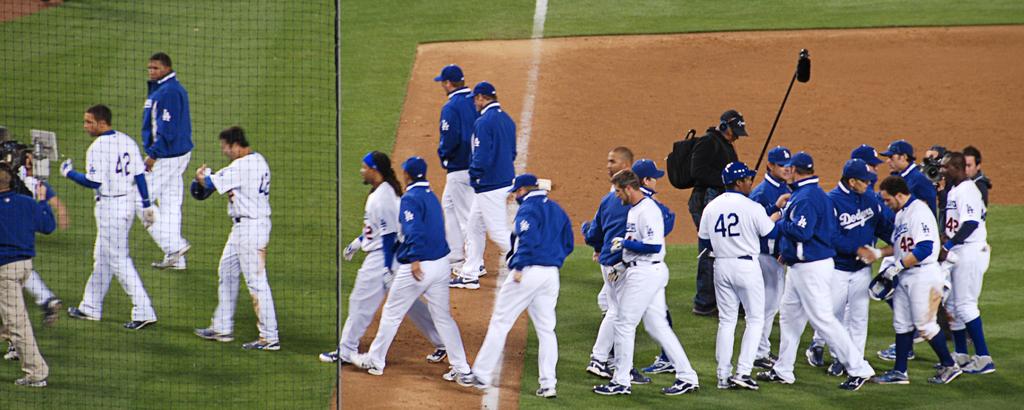What number can be seen on one of the jerseys in white?
Offer a very short reply. 42. 